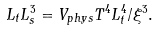<formula> <loc_0><loc_0><loc_500><loc_500>L _ { t } L _ { s } ^ { 3 } = V _ { p h y s } T ^ { 4 } L _ { t } ^ { 4 } / \xi ^ { 3 } .</formula> 